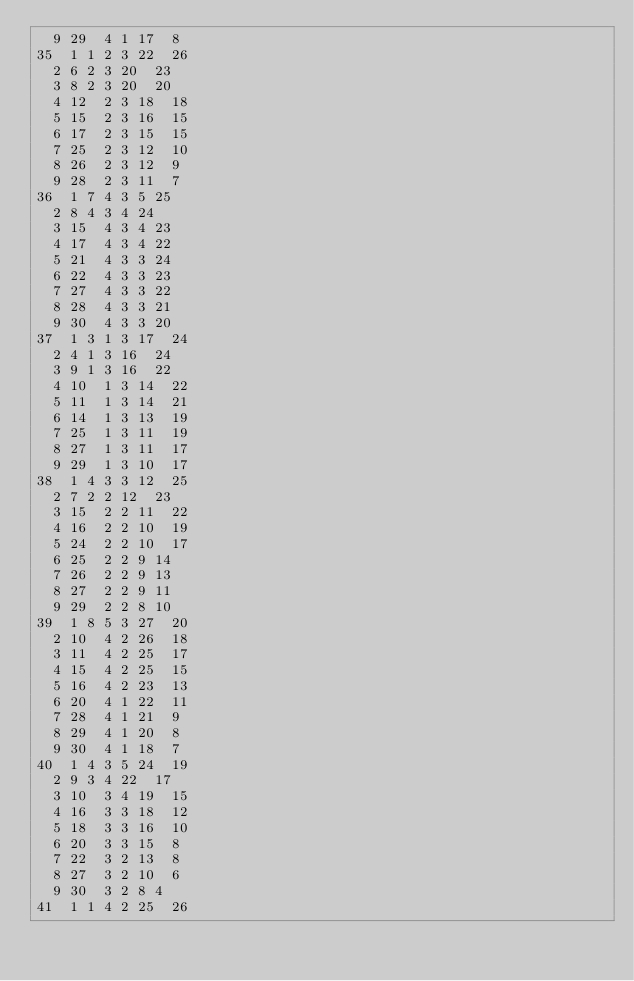<code> <loc_0><loc_0><loc_500><loc_500><_ObjectiveC_>	9	29	4	1	17	8	
35	1	1	2	3	22	26	
	2	6	2	3	20	23	
	3	8	2	3	20	20	
	4	12	2	3	18	18	
	5	15	2	3	16	15	
	6	17	2	3	15	15	
	7	25	2	3	12	10	
	8	26	2	3	12	9	
	9	28	2	3	11	7	
36	1	7	4	3	5	25	
	2	8	4	3	4	24	
	3	15	4	3	4	23	
	4	17	4	3	4	22	
	5	21	4	3	3	24	
	6	22	4	3	3	23	
	7	27	4	3	3	22	
	8	28	4	3	3	21	
	9	30	4	3	3	20	
37	1	3	1	3	17	24	
	2	4	1	3	16	24	
	3	9	1	3	16	22	
	4	10	1	3	14	22	
	5	11	1	3	14	21	
	6	14	1	3	13	19	
	7	25	1	3	11	19	
	8	27	1	3	11	17	
	9	29	1	3	10	17	
38	1	4	3	3	12	25	
	2	7	2	2	12	23	
	3	15	2	2	11	22	
	4	16	2	2	10	19	
	5	24	2	2	10	17	
	6	25	2	2	9	14	
	7	26	2	2	9	13	
	8	27	2	2	9	11	
	9	29	2	2	8	10	
39	1	8	5	3	27	20	
	2	10	4	2	26	18	
	3	11	4	2	25	17	
	4	15	4	2	25	15	
	5	16	4	2	23	13	
	6	20	4	1	22	11	
	7	28	4	1	21	9	
	8	29	4	1	20	8	
	9	30	4	1	18	7	
40	1	4	3	5	24	19	
	2	9	3	4	22	17	
	3	10	3	4	19	15	
	4	16	3	3	18	12	
	5	18	3	3	16	10	
	6	20	3	3	15	8	
	7	22	3	2	13	8	
	8	27	3	2	10	6	
	9	30	3	2	8	4	
41	1	1	4	2	25	26	</code> 